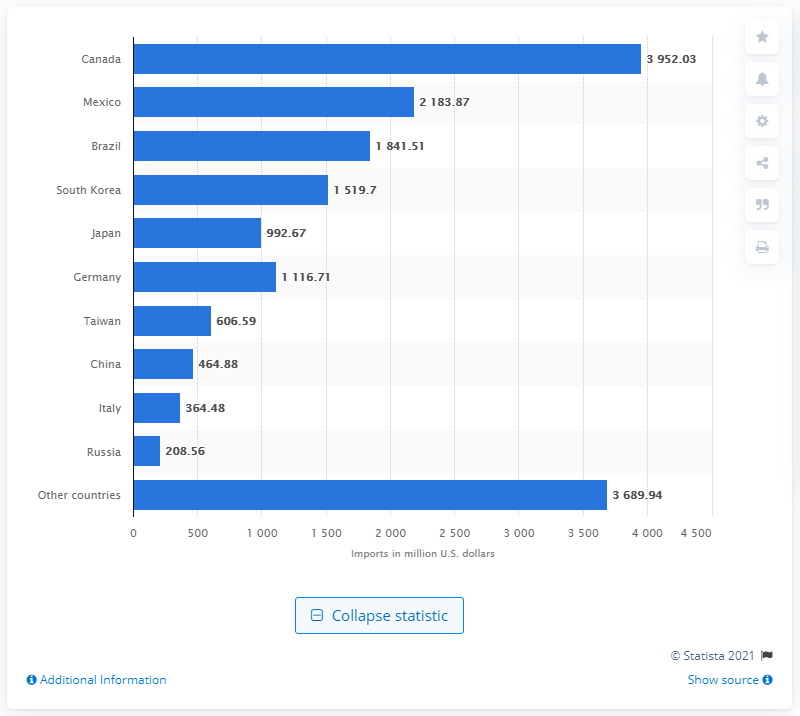Point out several critical features in this image. In 2020, the majority of U.S. steel imports came from Canada. 